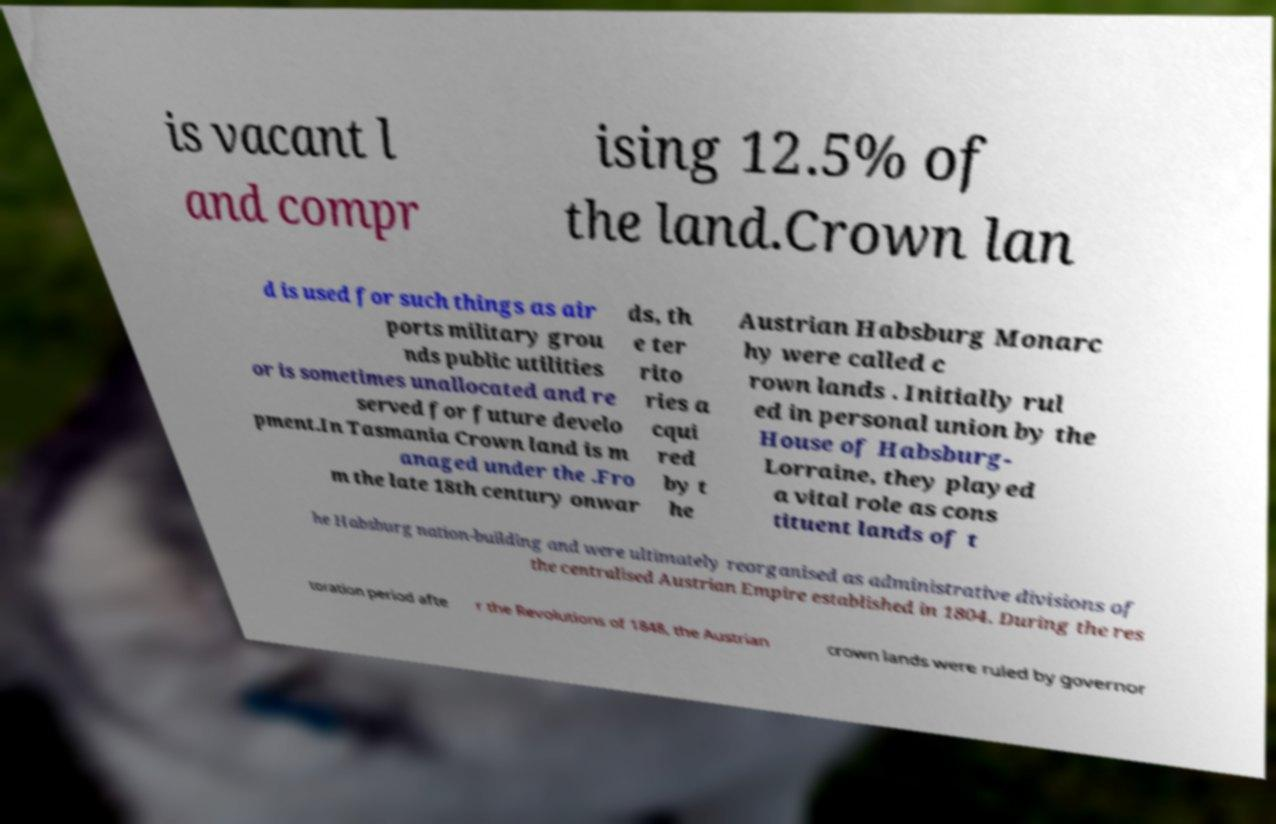Please read and relay the text visible in this image. What does it say? is vacant l and compr ising 12.5% of the land.Crown lan d is used for such things as air ports military grou nds public utilities or is sometimes unallocated and re served for future develo pment.In Tasmania Crown land is m anaged under the .Fro m the late 18th century onwar ds, th e ter rito ries a cqui red by t he Austrian Habsburg Monarc hy were called c rown lands . Initially rul ed in personal union by the House of Habsburg- Lorraine, they played a vital role as cons tituent lands of t he Habsburg nation-building and were ultimately reorganised as administrative divisions of the centralised Austrian Empire established in 1804. During the res toration period afte r the Revolutions of 1848, the Austrian crown lands were ruled by governor 